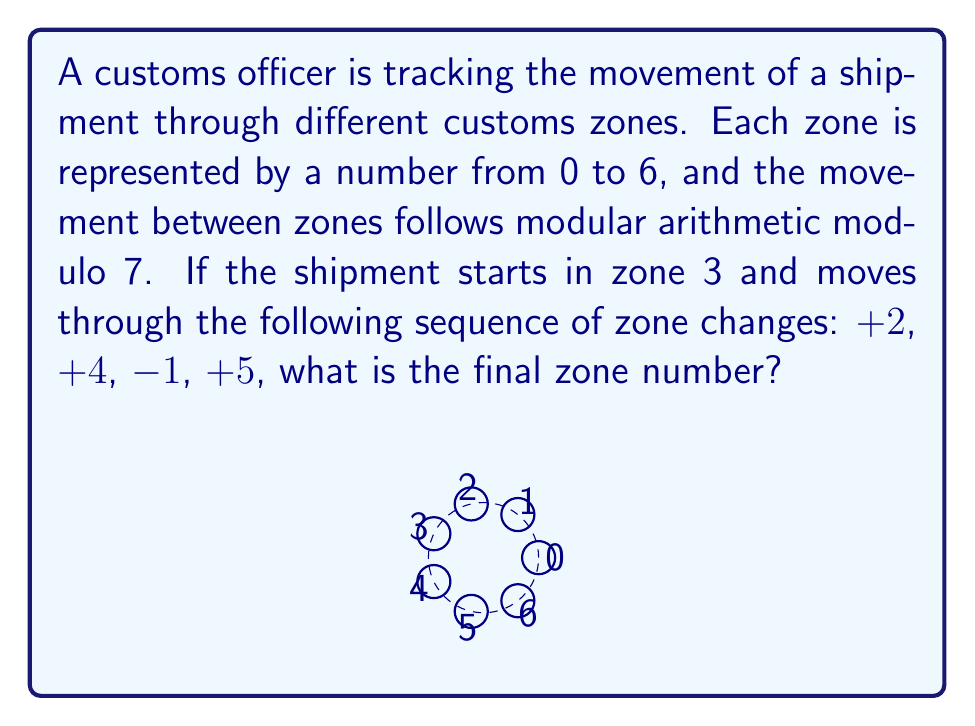Teach me how to tackle this problem. Let's solve this step-by-step using modular arithmetic modulo 7:

1) Initial zone: 3

2) First movement: +2
   $$(3 + 2) \mod 7 = 5$$

3) Second movement: +4
   $$(5 + 4) \mod 7 = 9 \mod 7 = 2$$

4) Third movement: -1
   $$(2 - 1) \mod 7 = 1$$
   Note: In modular arithmetic, negative numbers are handled by adding the modulus until a positive number is obtained. So, 1 is correct here.

5) Fourth movement: +5
   $$(1 + 5) \mod 7 = 6$$

Therefore, the final zone number is 6.
Answer: 6 